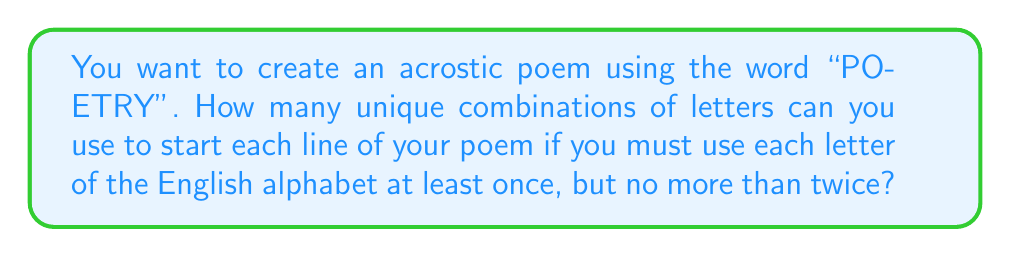What is the answer to this math problem? Let's approach this step-by-step:

1) The word "POETRY" has 6 letters, so we need to choose 6 letters to start each line.

2) We must use each letter of the alphabet at least once. There are 26 letters in the English alphabet.

3) After using all 26 letters once, we have 6 - 26 = -20 spots left. This means we need to use 20 letters twice to fill all 6 lines of our acrostic poem.

4) This is equivalent to choosing 20 letters from the 26 to be used twice.

5) This is a combination problem. We can calculate it using the formula:

   $$\binom{26}{20} = \frac{26!}{20!(26-20)!} = \frac{26!}{20!6!}$$

6) Calculating this:
   
   $$\frac{26 * 25 * 24 * 23 * 22 * 21 * 20!}{20! * 6 * 5 * 4 * 3 * 2 * 1}$$

7) The 20! cancels out in the numerator and denominator:

   $$\frac{26 * 25 * 24 * 23 * 22 * 21}{6 * 5 * 4 * 3 * 2 * 1} = 230,230$$

Therefore, there are 230,230 unique ways to choose which letters will be used twice.
Answer: 230,230 